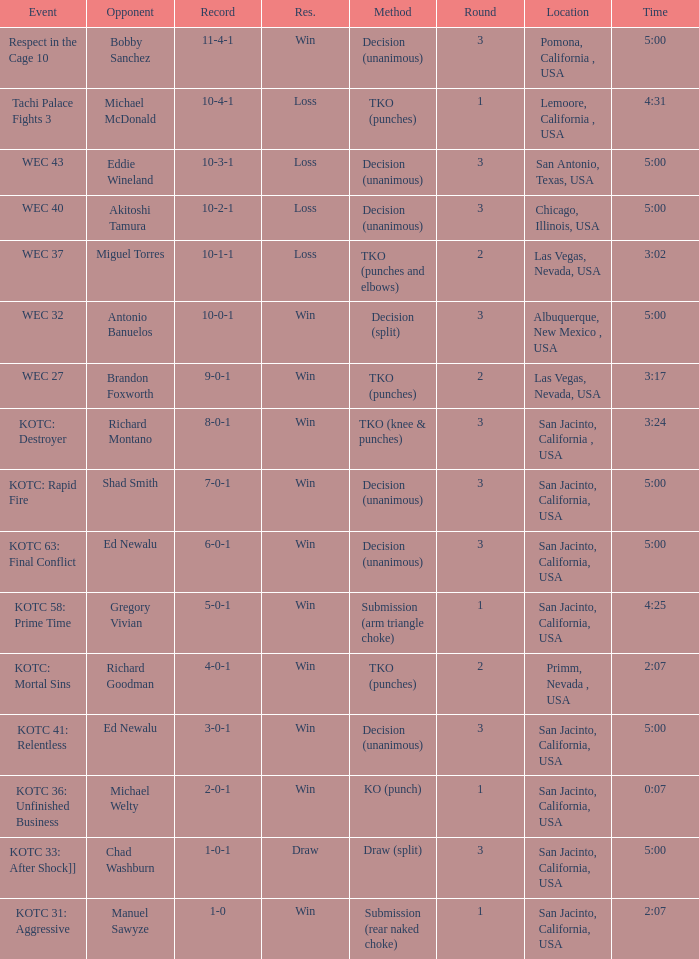What location did the event kotc: mortal sins take place? Primm, Nevada , USA. Help me parse the entirety of this table. {'header': ['Event', 'Opponent', 'Record', 'Res.', 'Method', 'Round', 'Location', 'Time'], 'rows': [['Respect in the Cage 10', 'Bobby Sanchez', '11-4-1', 'Win', 'Decision (unanimous)', '3', 'Pomona, California , USA', '5:00'], ['Tachi Palace Fights 3', 'Michael McDonald', '10-4-1', 'Loss', 'TKO (punches)', '1', 'Lemoore, California , USA', '4:31'], ['WEC 43', 'Eddie Wineland', '10-3-1', 'Loss', 'Decision (unanimous)', '3', 'San Antonio, Texas, USA', '5:00'], ['WEC 40', 'Akitoshi Tamura', '10-2-1', 'Loss', 'Decision (unanimous)', '3', 'Chicago, Illinois, USA', '5:00'], ['WEC 37', 'Miguel Torres', '10-1-1', 'Loss', 'TKO (punches and elbows)', '2', 'Las Vegas, Nevada, USA', '3:02'], ['WEC 32', 'Antonio Banuelos', '10-0-1', 'Win', 'Decision (split)', '3', 'Albuquerque, New Mexico , USA', '5:00'], ['WEC 27', 'Brandon Foxworth', '9-0-1', 'Win', 'TKO (punches)', '2', 'Las Vegas, Nevada, USA', '3:17'], ['KOTC: Destroyer', 'Richard Montano', '8-0-1', 'Win', 'TKO (knee & punches)', '3', 'San Jacinto, California , USA', '3:24'], ['KOTC: Rapid Fire', 'Shad Smith', '7-0-1', 'Win', 'Decision (unanimous)', '3', 'San Jacinto, California, USA', '5:00'], ['KOTC 63: Final Conflict', 'Ed Newalu', '6-0-1', 'Win', 'Decision (unanimous)', '3', 'San Jacinto, California, USA', '5:00'], ['KOTC 58: Prime Time', 'Gregory Vivian', '5-0-1', 'Win', 'Submission (arm triangle choke)', '1', 'San Jacinto, California, USA', '4:25'], ['KOTC: Mortal Sins', 'Richard Goodman', '4-0-1', 'Win', 'TKO (punches)', '2', 'Primm, Nevada , USA', '2:07'], ['KOTC 41: Relentless', 'Ed Newalu', '3-0-1', 'Win', 'Decision (unanimous)', '3', 'San Jacinto, California, USA', '5:00'], ['KOTC 36: Unfinished Business', 'Michael Welty', '2-0-1', 'Win', 'KO (punch)', '1', 'San Jacinto, California, USA', '0:07'], ['KOTC 33: After Shock]]', 'Chad Washburn', '1-0-1', 'Draw', 'Draw (split)', '3', 'San Jacinto, California, USA', '5:00'], ['KOTC 31: Aggressive', 'Manuel Sawyze', '1-0', 'Win', 'Submission (rear naked choke)', '1', 'San Jacinto, California, USA', '2:07']]} 